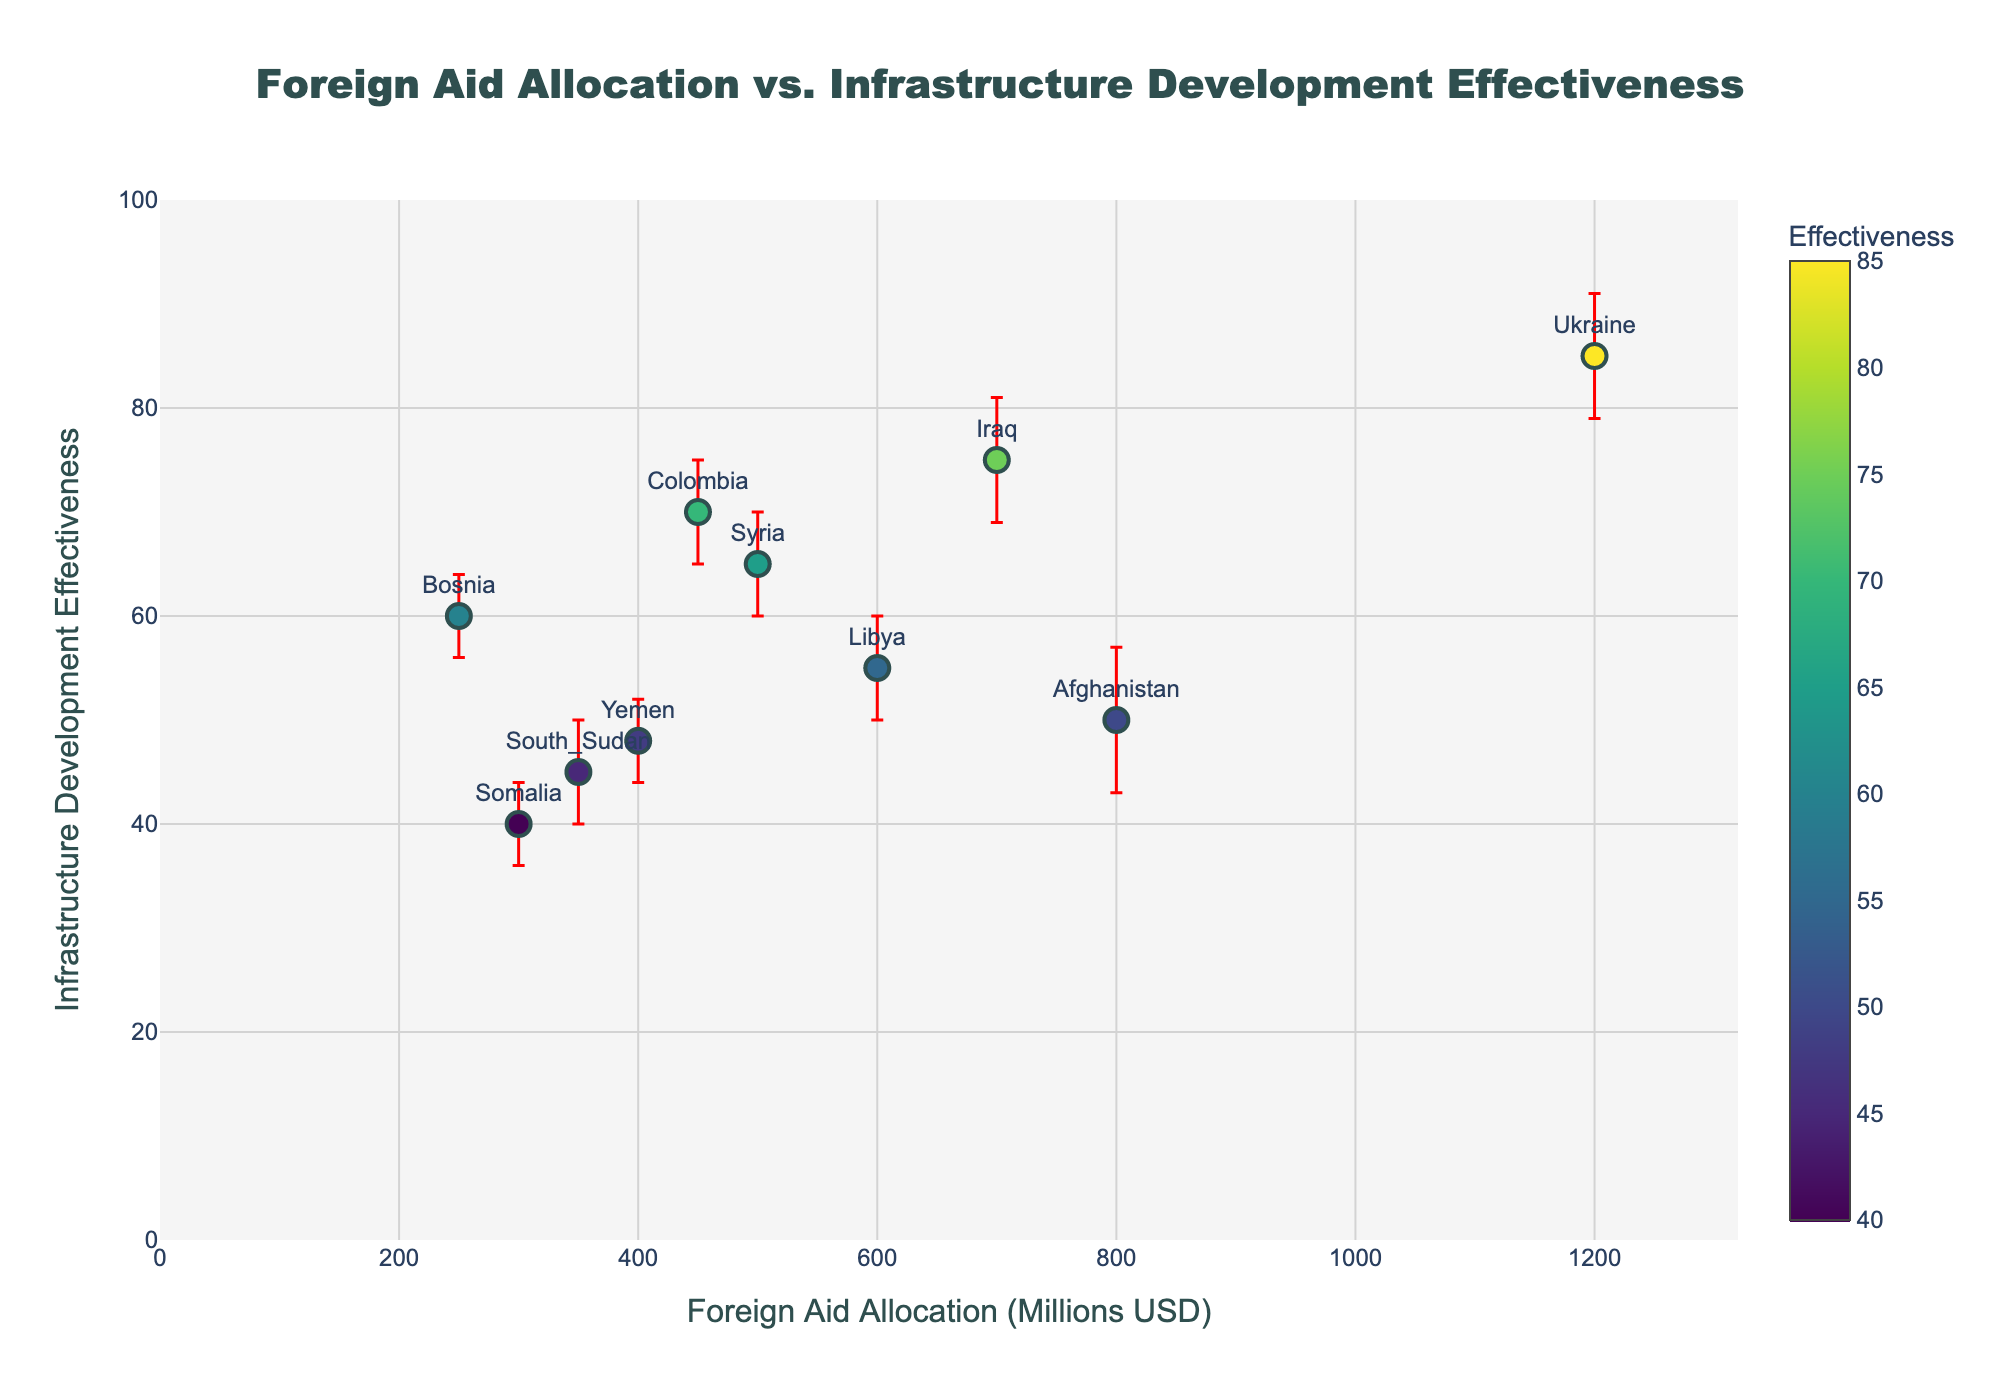What's the title of the plot? The title is located at the top center of the plot. It reads: "Foreign Aid Allocation vs. Infrastructure Development Effectiveness".
Answer: Foreign Aid Allocation vs. Infrastructure Development Effectiveness What is the foreign aid allocation for Ukraine? To find the foreign aid allocation for Ukraine, locate the point labeled "Ukraine" on the x-axis, which corresponds to $1,200 million.
Answer: 1200 million USD Which country has the lowest infrastructure development effectiveness? Find the point with the lowest y-value on the vertical axis, which is labeled "Infrastructure Development Effectiveness." Somalia has the lowest effectiveness at a value of 40.
Answer: Somalia What is the average foreign aid allocation for Syria and Yemen? The foreign aid allocation for Syria is 500 million USD and for Yemen is 400 million USD. The average is calculated by adding these two values and dividing by 2: (500 + 400) / 2 = 450 million USD.
Answer: 450 million USD How many countries have an infrastructure development effectiveness higher than 60? Look at the y-axis labeled "Infrastructure Development Effectiveness" and count the points above 60. These points correspond to Syria, Iraq, Ukraine, and Colombia, totaling 4 countries.
Answer: 4 What is the difference in infrastructure development effectiveness between Libya and Afghanistan? Find Libya and Afghanistan on the y-axis. Libya has an effectiveness of 55, while Afghanistan has 50. The difference is 55 - 50 = 5.
Answer: 5 Which country has the highest error margin in infrastructure development effectiveness? Locate the points with error bars on the plot. The country with the longest error bar in the vertical direction is Afghanistan, with an error of 7.
Answer: Afghanistan Among Iraq and South Sudan, which has a higher infrastructure development effectiveness? Compare the y-values of Iraq and South Sudan. Iraq has an effectiveness of 75, while South Sudan has 45. Therefore, Iraq has a higher effectiveness.
Answer: Iraq What color represents countries with the highest effectiveness? The color scale for effectiveness is given on the right side of the plot. Countries with the highest effectiveness are closer to the yellow end of the Viridis color scale.
Answer: Yellow What is the total foreign aid allocation for Somalia, Bosnia, and Colombia combined? Add the foreign aid allocations for Somalia (300 million USD), Bosnia (250 million USD), and Colombia (450 million USD): 300 + 250 + 450 = 1000 million USD.
Answer: 1000 million USD 